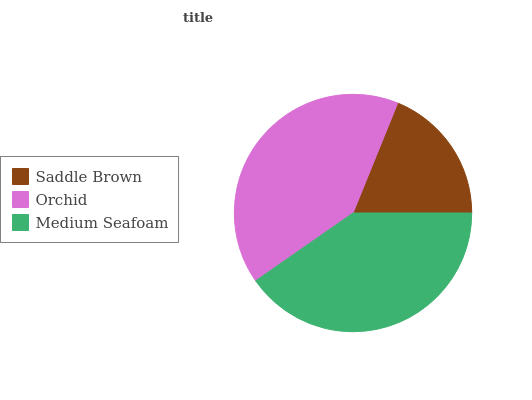Is Saddle Brown the minimum?
Answer yes or no. Yes. Is Orchid the maximum?
Answer yes or no. Yes. Is Medium Seafoam the minimum?
Answer yes or no. No. Is Medium Seafoam the maximum?
Answer yes or no. No. Is Orchid greater than Medium Seafoam?
Answer yes or no. Yes. Is Medium Seafoam less than Orchid?
Answer yes or no. Yes. Is Medium Seafoam greater than Orchid?
Answer yes or no. No. Is Orchid less than Medium Seafoam?
Answer yes or no. No. Is Medium Seafoam the high median?
Answer yes or no. Yes. Is Medium Seafoam the low median?
Answer yes or no. Yes. Is Orchid the high median?
Answer yes or no. No. Is Saddle Brown the low median?
Answer yes or no. No. 